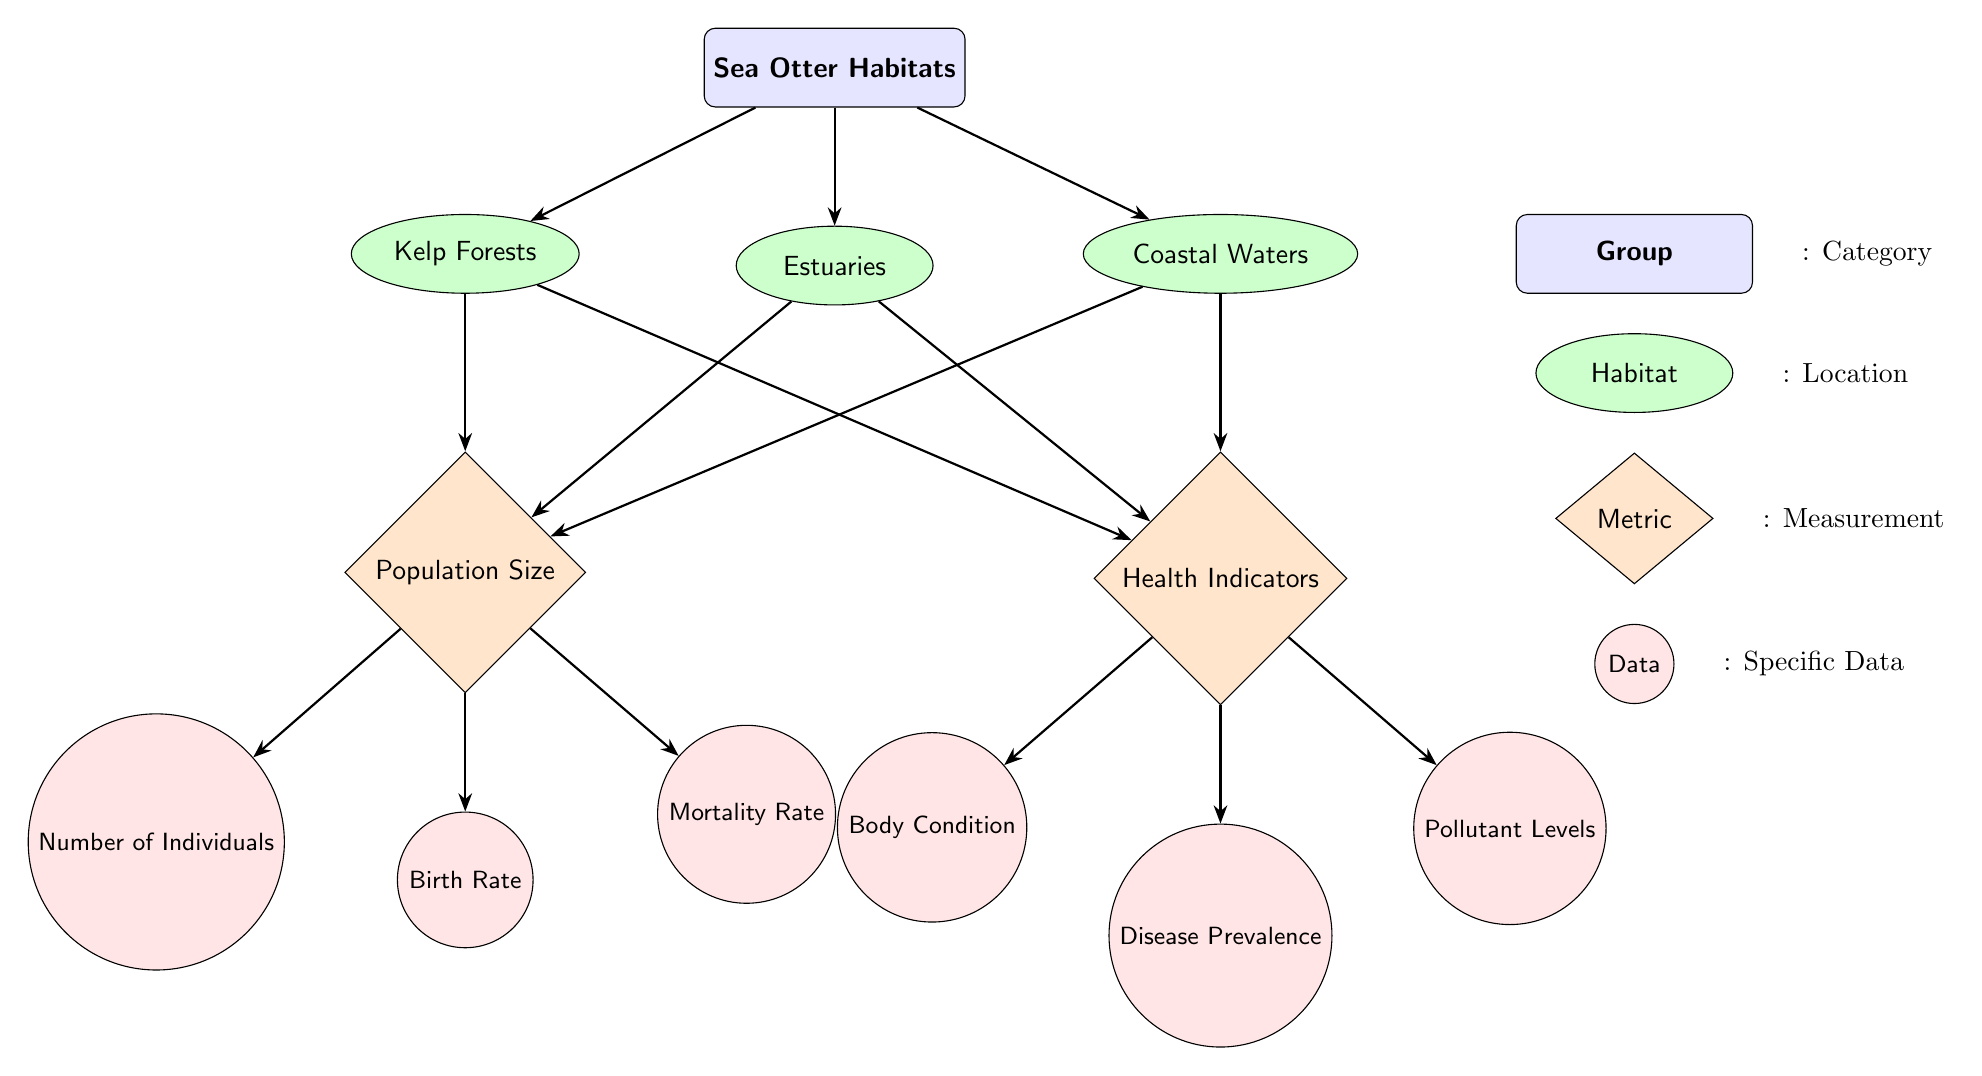What are the three habitats listed in the diagram? The diagram identifies three habitats for sea otters: Kelp Forests, Estuaries, and Coastal Waters. This information is directly visible in the "Sea Otter Habitats" group.
Answer: Kelp Forests, Estuaries, Coastal Waters How many metrics are used to measure population size? The diagram shows that there are three metrics related to population size: Number of Individuals, Birth Rate, and Mortality Rate. This can be found under the "Population Size" metric.
Answer: 3 What health indicator focuses on the presence of harmful substances? The diagram lists "Pollutant Levels" as one of the health indicators affecting sea otters, which focuses on the presence of harmful substances in their habitat. This is positioned under the "Health Indicators" metric.
Answer: Pollutant Levels Which habitat has a direct influence on both population size and health indicators? The "Estuaries" node directly connects to both the "Population Size" and "Health Indicators" metrics, indicating it affects both aspects. This can be deduced from the directed edges leading from the Estuaries node in the diagram.
Answer: Estuaries If the mortality rate increases, what other population size metric might be affected? An increase in the mortality rate would likely reduce the "Number of Individuals" in the population, as more individuals would be lost. This relationship is indicated by the connection from the mortality node to the population metrics in the diagram.
Answer: Number of Individuals Which health indicator is associated with assessing the general physical well-being of the sea otters? "Body Condition" is the health indicator that is associated with assessing the general physical well-being of sea otters, as it reflects their overall health. This indicator is linked under the "Health Indicators" metric.
Answer: Body Condition What type of relationship is depicted between habitats and metrics in the diagram? The relationship between habitats and metrics is shown as a directed flow from the habitats to both the population size metrics and health indicators, indicating influence or effect. This structural organization can be inferred from the arrows originating from the habitat nodes.
Answer: Influence What is the purpose of having both population size and health metrics in the same diagram? Including both population size and health metrics serves to provide a comprehensive overview of the sea otter populations, indicating not only how many individuals are present but also their health status, which is crucial for conservation efforts. This rationale is implied by the interconnectedness of the metrics in the diagram.
Answer: Comprehensive overview 